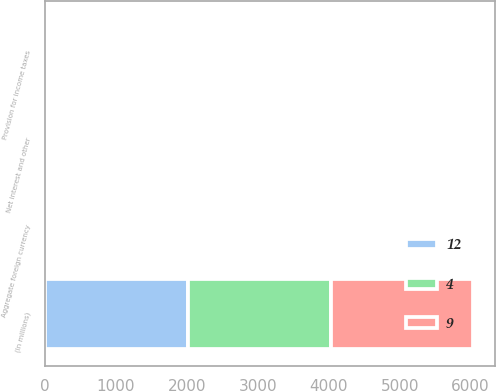<chart> <loc_0><loc_0><loc_500><loc_500><stacked_bar_chart><ecel><fcel>(In millions)<fcel>Net interest and other<fcel>Provision for income taxes<fcel>Aggregate foreign currency<nl><fcel>12<fcel>2014<fcel>21<fcel>12<fcel>9<nl><fcel>4<fcel>2013<fcel>14<fcel>2<fcel>12<nl><fcel>9<fcel>2012<fcel>2<fcel>2<fcel>4<nl></chart> 